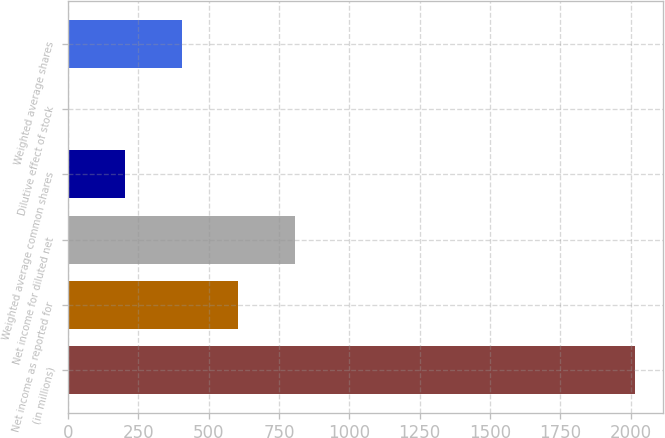Convert chart to OTSL. <chart><loc_0><loc_0><loc_500><loc_500><bar_chart><fcel>(in millions)<fcel>Net income as reported for<fcel>Net income for diluted net<fcel>Weighted average common shares<fcel>Dilutive effect of stock<fcel>Weighted average shares<nl><fcel>2014<fcel>605.53<fcel>806.74<fcel>203.11<fcel>1.9<fcel>404.32<nl></chart> 